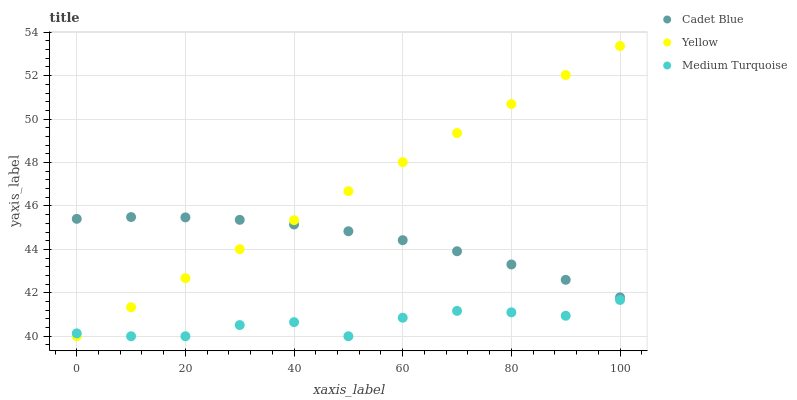Does Medium Turquoise have the minimum area under the curve?
Answer yes or no. Yes. Does Yellow have the maximum area under the curve?
Answer yes or no. Yes. Does Yellow have the minimum area under the curve?
Answer yes or no. No. Does Medium Turquoise have the maximum area under the curve?
Answer yes or no. No. Is Yellow the smoothest?
Answer yes or no. Yes. Is Medium Turquoise the roughest?
Answer yes or no. Yes. Is Medium Turquoise the smoothest?
Answer yes or no. No. Is Yellow the roughest?
Answer yes or no. No. Does Medium Turquoise have the lowest value?
Answer yes or no. Yes. Does Yellow have the highest value?
Answer yes or no. Yes. Does Medium Turquoise have the highest value?
Answer yes or no. No. Is Medium Turquoise less than Cadet Blue?
Answer yes or no. Yes. Is Cadet Blue greater than Medium Turquoise?
Answer yes or no. Yes. Does Cadet Blue intersect Yellow?
Answer yes or no. Yes. Is Cadet Blue less than Yellow?
Answer yes or no. No. Is Cadet Blue greater than Yellow?
Answer yes or no. No. Does Medium Turquoise intersect Cadet Blue?
Answer yes or no. No. 